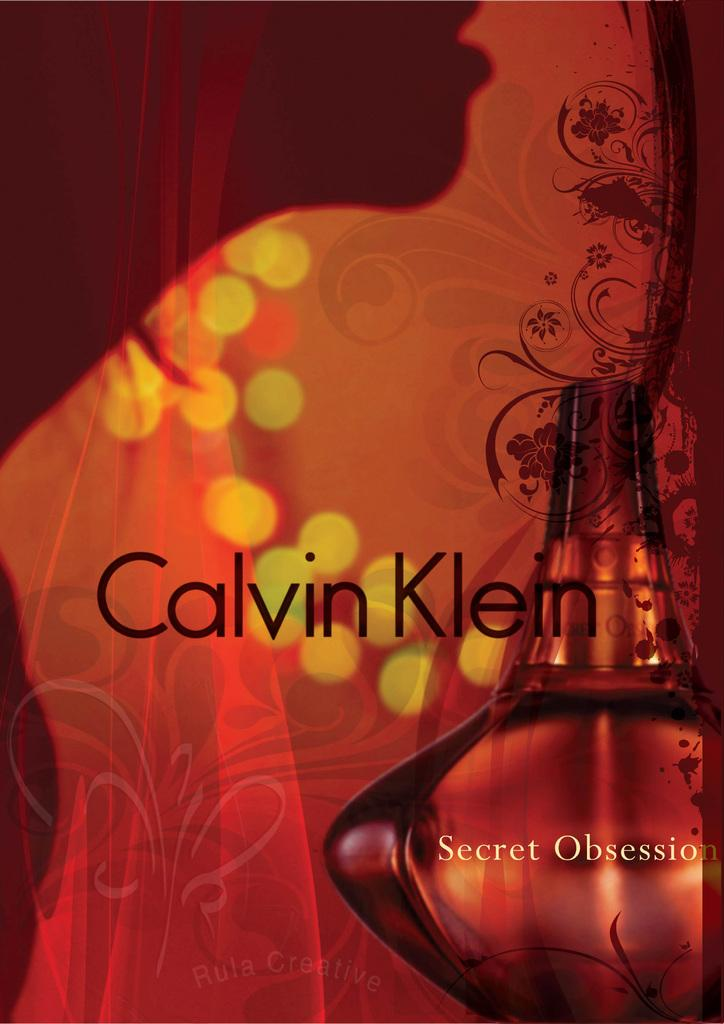<image>
Share a concise interpretation of the image provided. A perfume by Calvin Klein called Secret Obsession is shown with a red and orange background. 